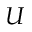Convert formula to latex. <formula><loc_0><loc_0><loc_500><loc_500>U</formula> 